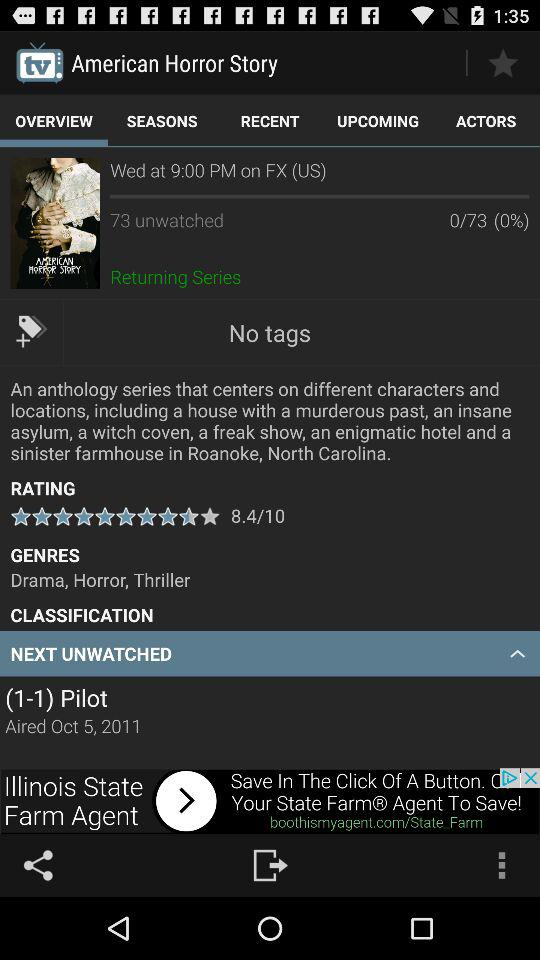On what date was the movie aired? The movie was aired on October 5, 2011. 